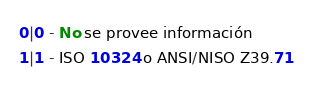Convert code to text. <code><loc_0><loc_0><loc_500><loc_500><_SQL_>0|0 - No se provee información
1|1 - ISO 10324 o ANSI/NISO Z39.71</code> 